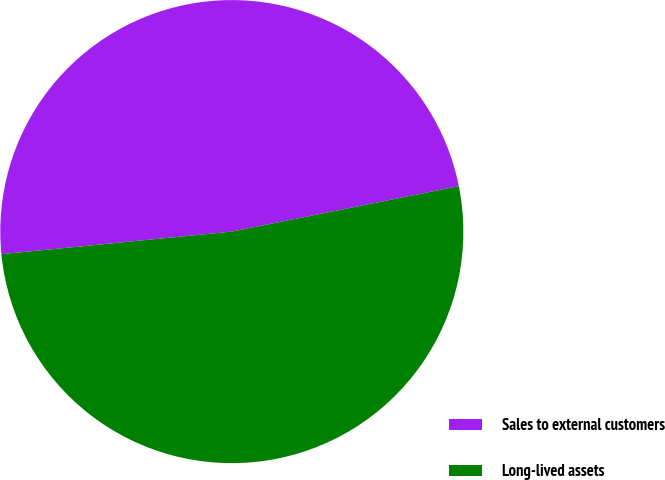Convert chart to OTSL. <chart><loc_0><loc_0><loc_500><loc_500><pie_chart><fcel>Sales to external customers<fcel>Long-lived assets<nl><fcel>48.41%<fcel>51.59%<nl></chart> 